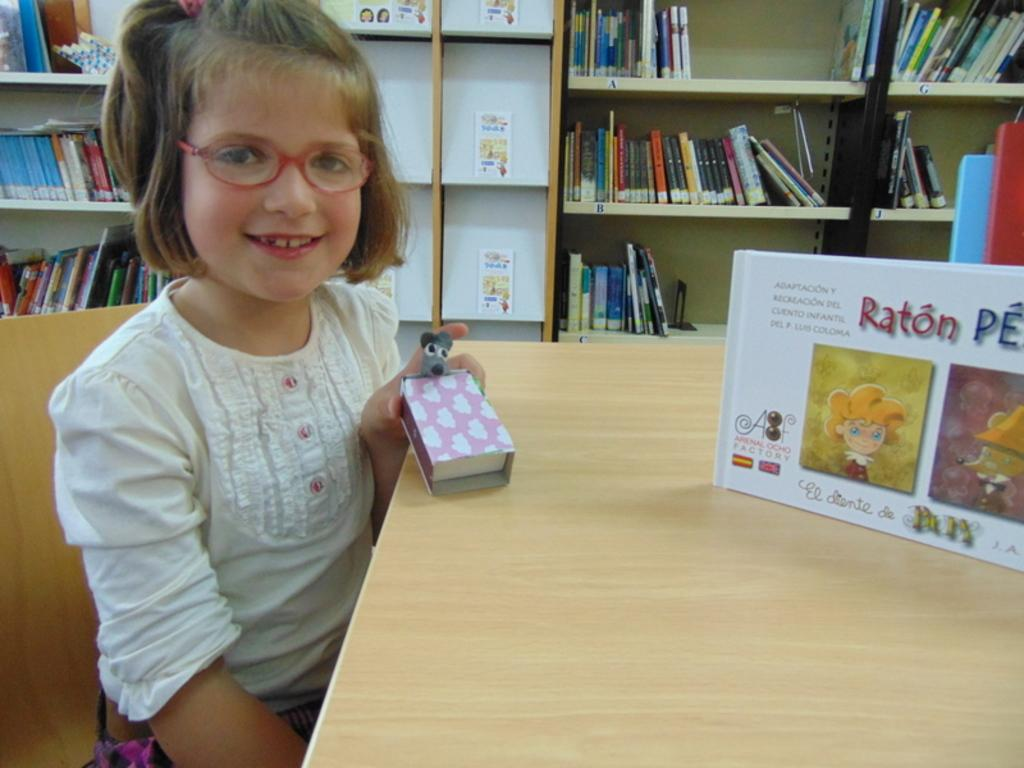Provide a one-sentence caption for the provided image. A young girl holds a Raton PE as she sits next to the box. 